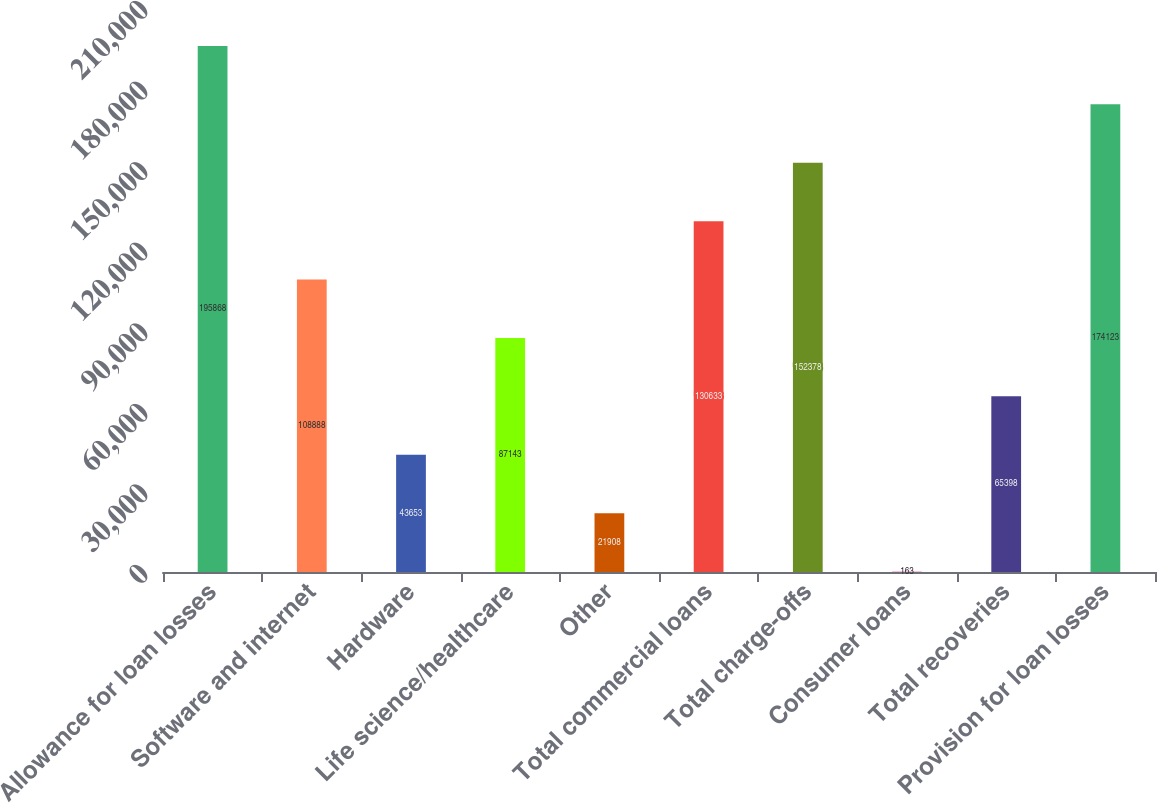Convert chart. <chart><loc_0><loc_0><loc_500><loc_500><bar_chart><fcel>Allowance for loan losses<fcel>Software and internet<fcel>Hardware<fcel>Life science/healthcare<fcel>Other<fcel>Total commercial loans<fcel>Total charge-offs<fcel>Consumer loans<fcel>Total recoveries<fcel>Provision for loan losses<nl><fcel>195868<fcel>108888<fcel>43653<fcel>87143<fcel>21908<fcel>130633<fcel>152378<fcel>163<fcel>65398<fcel>174123<nl></chart> 